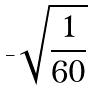Convert formula to latex. <formula><loc_0><loc_0><loc_500><loc_500>- \sqrt { \frac { 1 } { 6 0 } }</formula> 